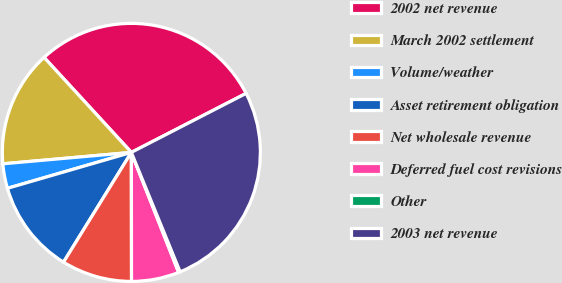Convert chart. <chart><loc_0><loc_0><loc_500><loc_500><pie_chart><fcel>2002 net revenue<fcel>March 2002 settlement<fcel>Volume/weather<fcel>Asset retirement obligation<fcel>Net wholesale revenue<fcel>Deferred fuel cost revisions<fcel>Other<fcel>2003 net revenue<nl><fcel>29.27%<fcel>14.58%<fcel>3.08%<fcel>11.7%<fcel>8.83%<fcel>5.95%<fcel>0.2%<fcel>26.39%<nl></chart> 